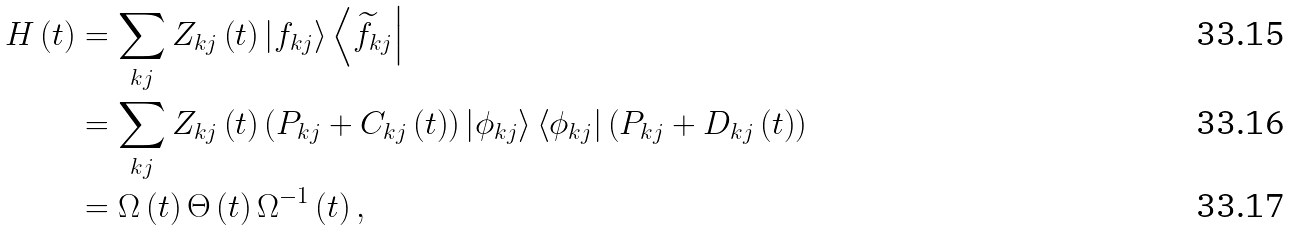<formula> <loc_0><loc_0><loc_500><loc_500>H \left ( t \right ) & = \sum _ { k j } Z _ { k j } \left ( t \right ) \left | f _ { k j } \right \rangle \left \langle \widetilde { f } _ { k j } \right | \\ & = \sum _ { k j } Z _ { k j } \left ( t \right ) \left ( P _ { k j } + C _ { k j } \left ( t \right ) \right ) \left | \phi _ { k j } \right \rangle \left \langle \phi _ { k j } \right | \left ( P _ { k j } + D _ { k j } \left ( t \right ) \right ) \\ & = \Omega \left ( t \right ) \Theta \left ( t \right ) \Omega ^ { - 1 } \left ( t \right ) ,</formula> 